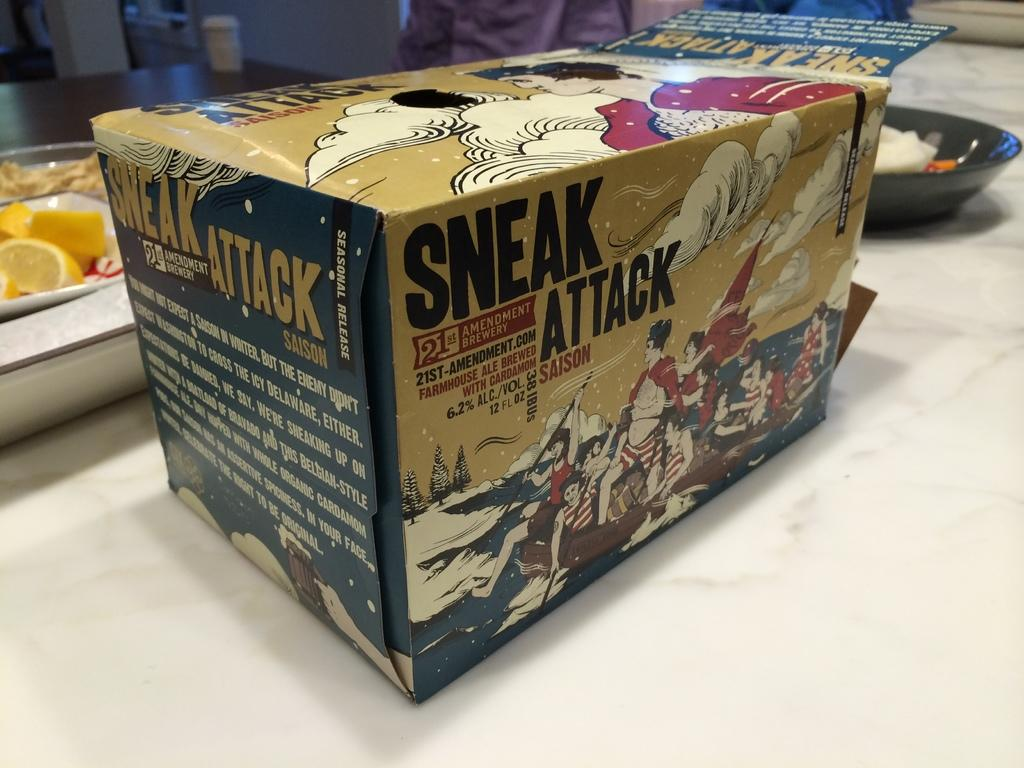<image>
Write a terse but informative summary of the picture. The box contains several beers from the 21st Amenment Brewery. 